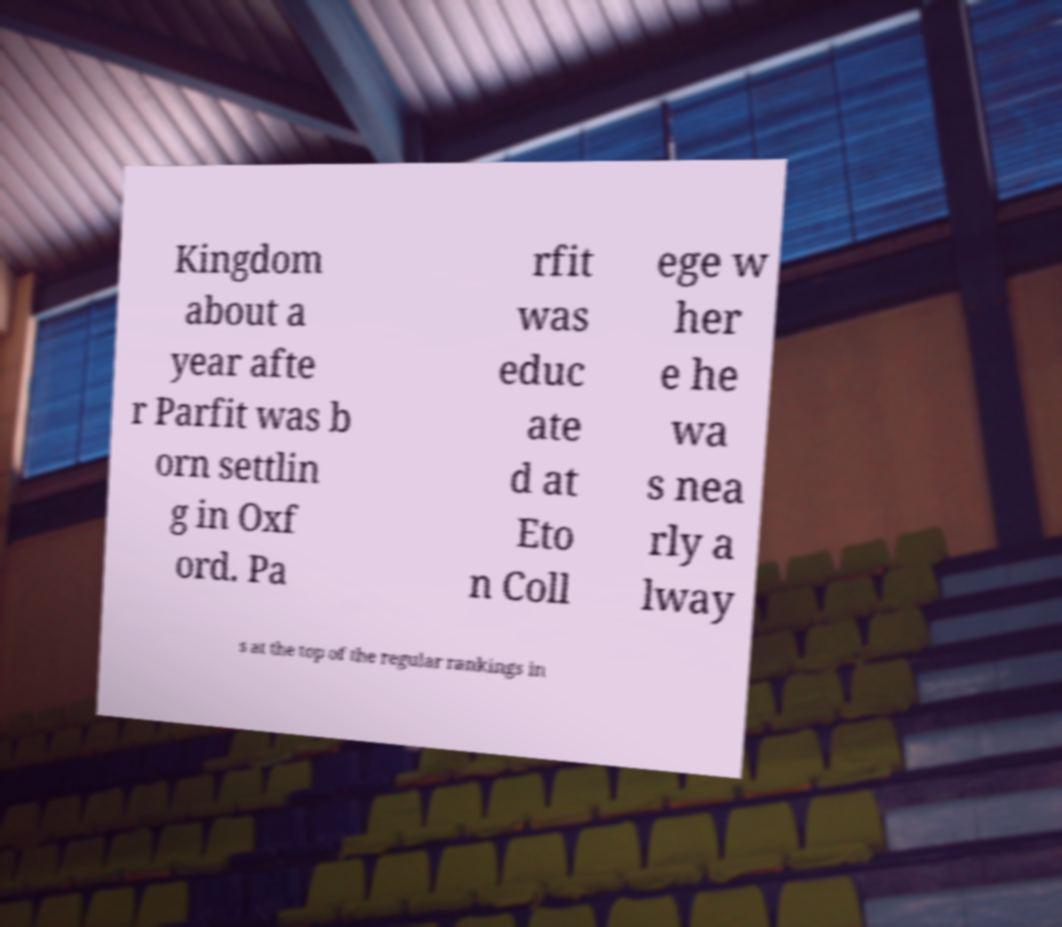Please identify and transcribe the text found in this image. Kingdom about a year afte r Parfit was b orn settlin g in Oxf ord. Pa rfit was educ ate d at Eto n Coll ege w her e he wa s nea rly a lway s at the top of the regular rankings in 